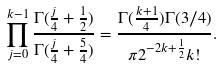<formula> <loc_0><loc_0><loc_500><loc_500>\prod _ { j = 0 } ^ { k - 1 } \frac { \Gamma ( \frac { j } { 4 } + \frac { 1 } { 2 } ) } { \Gamma ( \frac { j } { 4 } + \frac { 5 } { 4 } ) } = \frac { \Gamma ( \frac { k + 1 } { 4 } ) \Gamma ( 3 / 4 ) } { \pi 2 ^ { - 2 k + \frac { 1 } { 2 } } k ! } .</formula> 